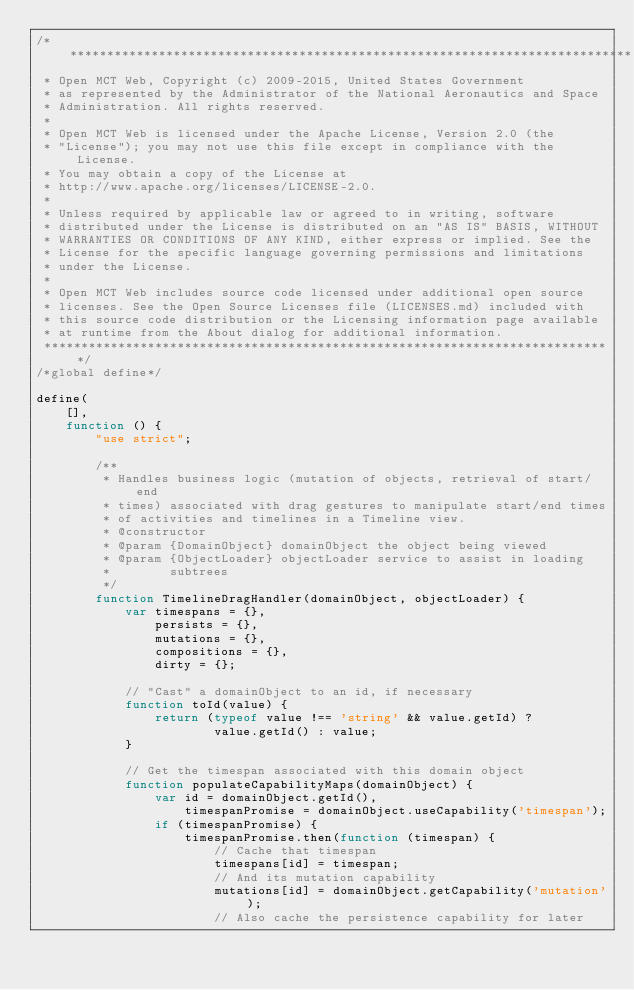Convert code to text. <code><loc_0><loc_0><loc_500><loc_500><_JavaScript_>/*****************************************************************************
 * Open MCT Web, Copyright (c) 2009-2015, United States Government
 * as represented by the Administrator of the National Aeronautics and Space
 * Administration. All rights reserved.
 *
 * Open MCT Web is licensed under the Apache License, Version 2.0 (the
 * "License"); you may not use this file except in compliance with the License.
 * You may obtain a copy of the License at
 * http://www.apache.org/licenses/LICENSE-2.0.
 *
 * Unless required by applicable law or agreed to in writing, software
 * distributed under the License is distributed on an "AS IS" BASIS, WITHOUT
 * WARRANTIES OR CONDITIONS OF ANY KIND, either express or implied. See the
 * License for the specific language governing permissions and limitations
 * under the License.
 *
 * Open MCT Web includes source code licensed under additional open source
 * licenses. See the Open Source Licenses file (LICENSES.md) included with
 * this source code distribution or the Licensing information page available
 * at runtime from the About dialog for additional information.
 *****************************************************************************/
/*global define*/

define(
    [],
    function () {
        "use strict";

        /**
         * Handles business logic (mutation of objects, retrieval of start/end
         * times) associated with drag gestures to manipulate start/end times
         * of activities and timelines in a Timeline view.
         * @constructor
         * @param {DomainObject} domainObject the object being viewed
         * @param {ObjectLoader} objectLoader service to assist in loading
         *        subtrees
         */
        function TimelineDragHandler(domainObject, objectLoader) {
            var timespans = {},
                persists = {},
                mutations = {},
                compositions = {},
                dirty = {};

            // "Cast" a domainObject to an id, if necessary
            function toId(value) {
                return (typeof value !== 'string' && value.getId) ?
                        value.getId() : value;
            }

            // Get the timespan associated with this domain object
            function populateCapabilityMaps(domainObject) {
                var id = domainObject.getId(),
                    timespanPromise = domainObject.useCapability('timespan');
                if (timespanPromise) {
                    timespanPromise.then(function (timespan) {
                        // Cache that timespan
                        timespans[id] = timespan;
                        // And its mutation capability
                        mutations[id] = domainObject.getCapability('mutation');
                        // Also cache the persistence capability for later</code> 